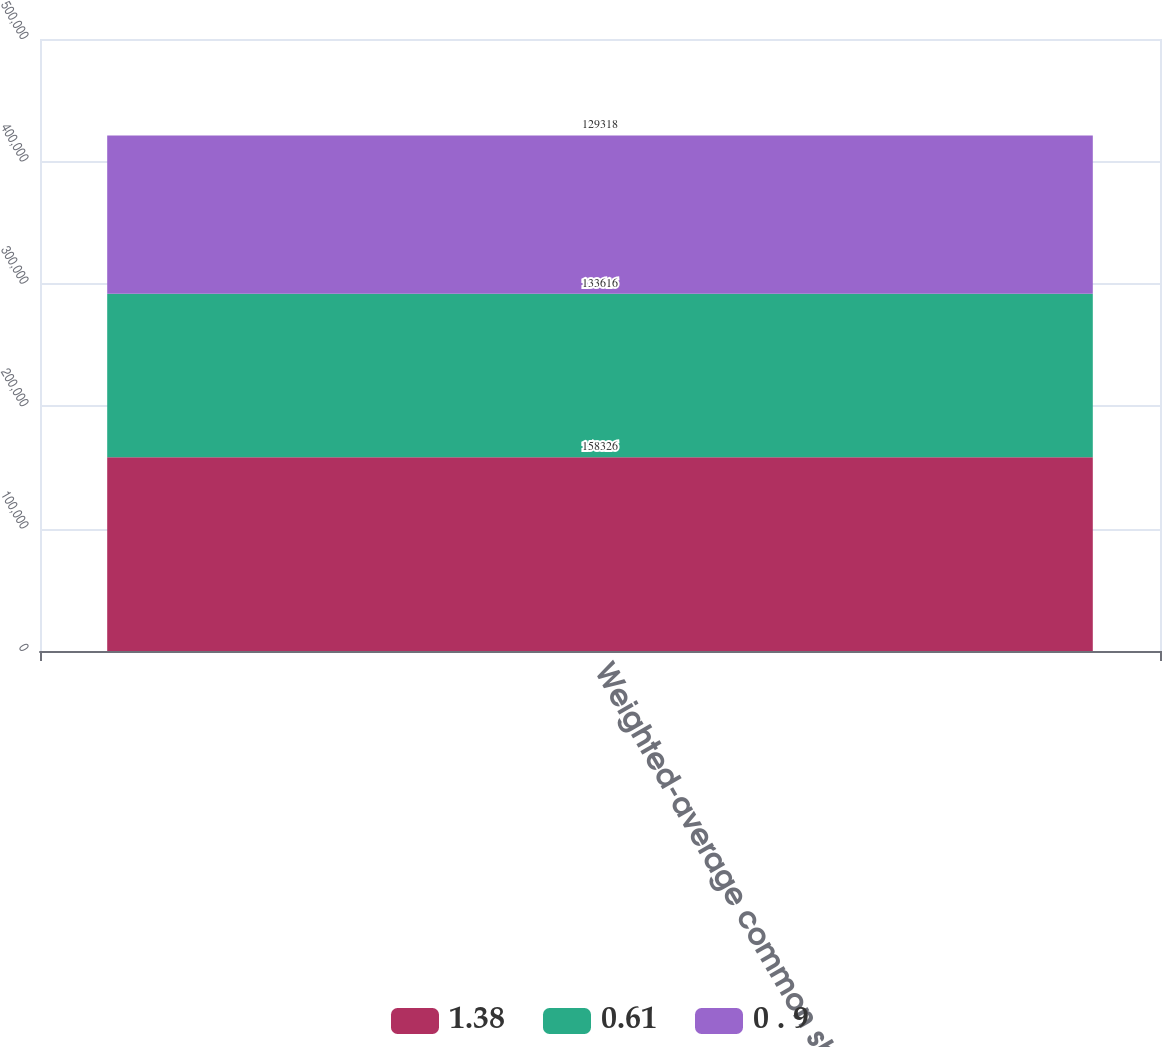Convert chart to OTSL. <chart><loc_0><loc_0><loc_500><loc_500><stacked_bar_chart><ecel><fcel>Weighted-average common shares<nl><fcel>1.38<fcel>158326<nl><fcel>0.61<fcel>133616<nl><fcel>0 . 9<fcel>129318<nl></chart> 